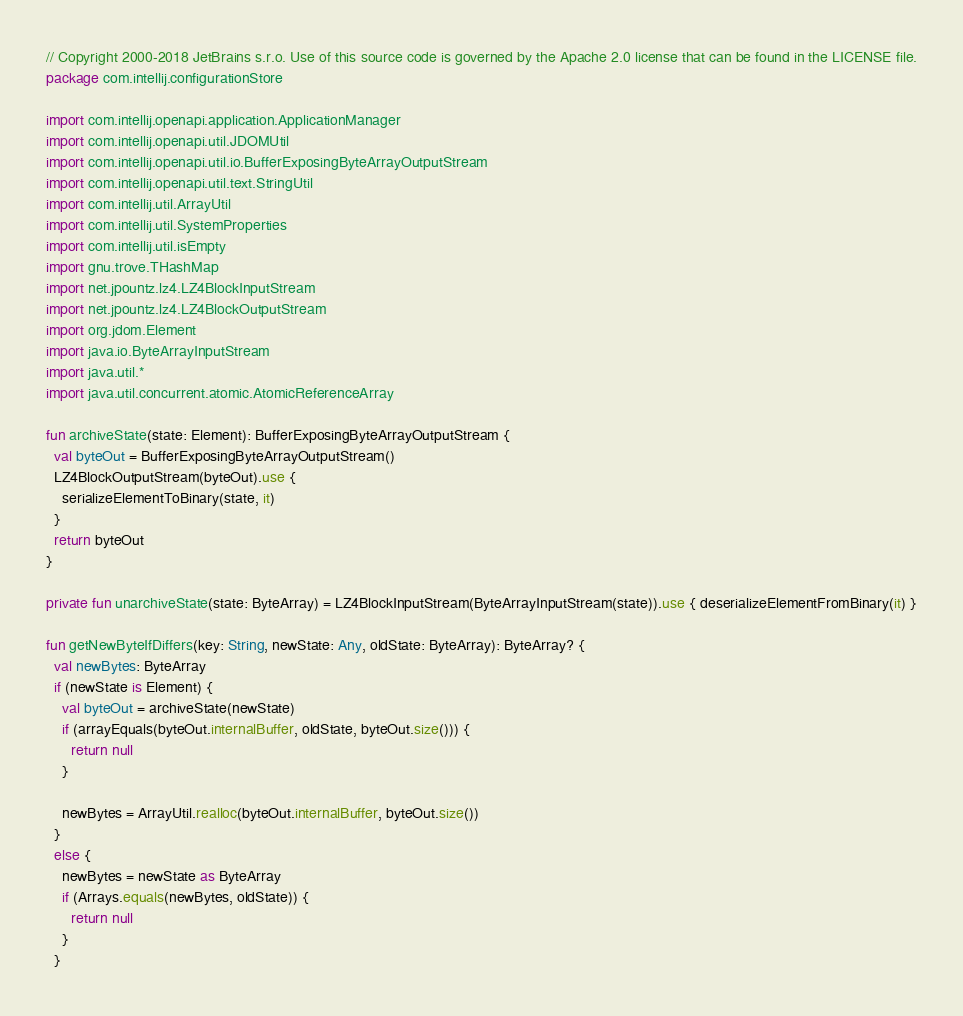<code> <loc_0><loc_0><loc_500><loc_500><_Kotlin_>// Copyright 2000-2018 JetBrains s.r.o. Use of this source code is governed by the Apache 2.0 license that can be found in the LICENSE file.
package com.intellij.configurationStore

import com.intellij.openapi.application.ApplicationManager
import com.intellij.openapi.util.JDOMUtil
import com.intellij.openapi.util.io.BufferExposingByteArrayOutputStream
import com.intellij.openapi.util.text.StringUtil
import com.intellij.util.ArrayUtil
import com.intellij.util.SystemProperties
import com.intellij.util.isEmpty
import gnu.trove.THashMap
import net.jpountz.lz4.LZ4BlockInputStream
import net.jpountz.lz4.LZ4BlockOutputStream
import org.jdom.Element
import java.io.ByteArrayInputStream
import java.util.*
import java.util.concurrent.atomic.AtomicReferenceArray

fun archiveState(state: Element): BufferExposingByteArrayOutputStream {
  val byteOut = BufferExposingByteArrayOutputStream()
  LZ4BlockOutputStream(byteOut).use {
    serializeElementToBinary(state, it)
  }
  return byteOut
}

private fun unarchiveState(state: ByteArray) = LZ4BlockInputStream(ByteArrayInputStream(state)).use { deserializeElementFromBinary(it) }

fun getNewByteIfDiffers(key: String, newState: Any, oldState: ByteArray): ByteArray? {
  val newBytes: ByteArray
  if (newState is Element) {
    val byteOut = archiveState(newState)
    if (arrayEquals(byteOut.internalBuffer, oldState, byteOut.size())) {
      return null
    }

    newBytes = ArrayUtil.realloc(byteOut.internalBuffer, byteOut.size())
  }
  else {
    newBytes = newState as ByteArray
    if (Arrays.equals(newBytes, oldState)) {
      return null
    }
  }
</code> 